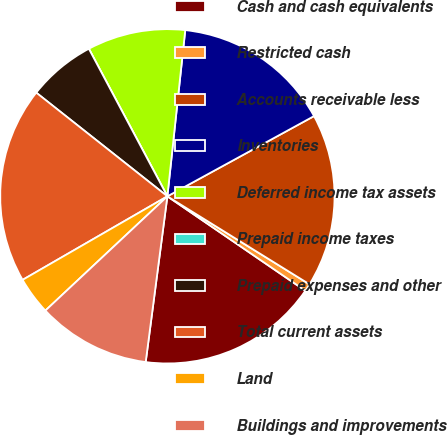Convert chart. <chart><loc_0><loc_0><loc_500><loc_500><pie_chart><fcel>Cash and cash equivalents<fcel>Restricted cash<fcel>Accounts receivable less<fcel>Inventories<fcel>Deferred income tax assets<fcel>Prepaid income taxes<fcel>Prepaid expenses and other<fcel>Total current assets<fcel>Land<fcel>Buildings and improvements<nl><fcel>17.52%<fcel>0.73%<fcel>16.79%<fcel>15.33%<fcel>9.49%<fcel>0.0%<fcel>6.57%<fcel>18.98%<fcel>3.65%<fcel>10.95%<nl></chart> 